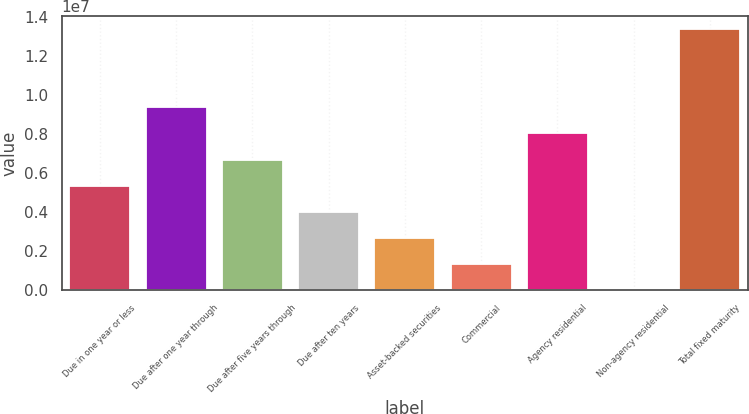<chart> <loc_0><loc_0><loc_500><loc_500><bar_chart><fcel>Due in one year or less<fcel>Due after one year through<fcel>Due after five years through<fcel>Due after ten years<fcel>Asset-backed securities<fcel>Commercial<fcel>Agency residential<fcel>Non-agency residential<fcel>Total fixed maturity<nl><fcel>5.34346e+06<fcel>9.35038e+06<fcel>6.6791e+06<fcel>4.00782e+06<fcel>2.67218e+06<fcel>1.33654e+06<fcel>8.01474e+06<fcel>898<fcel>1.33573e+07<nl></chart> 